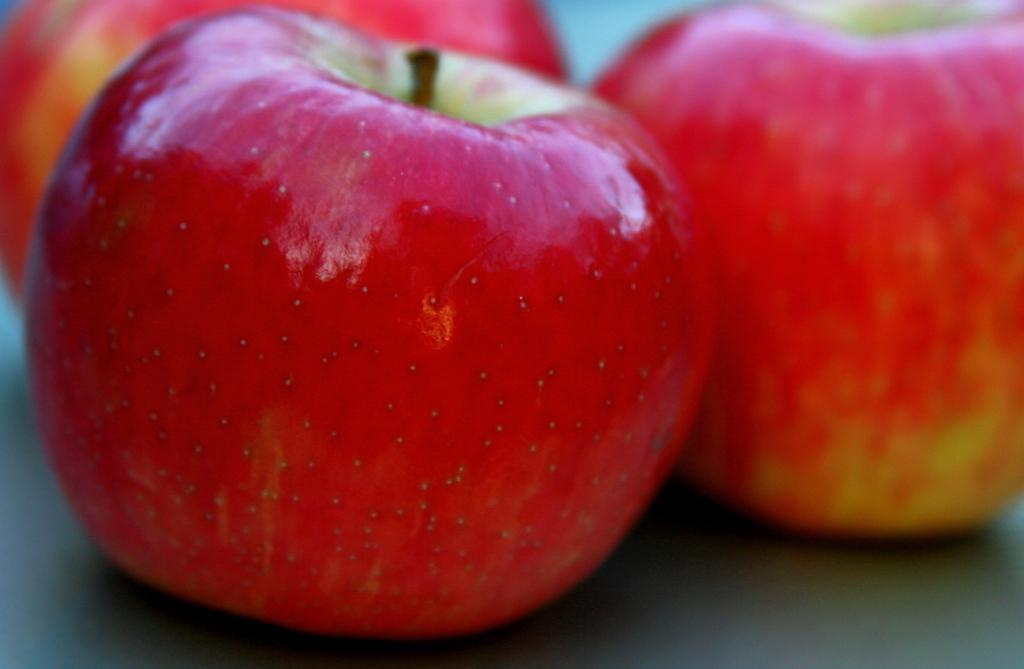How many apples are visible in the image? There are three apples in the image. Where are the apples located in the image? The apples are on a surface in the image. What is the nature of the argument taking place near the apples in the image? There is no argument present in the image; it only features three apples on a surface. 